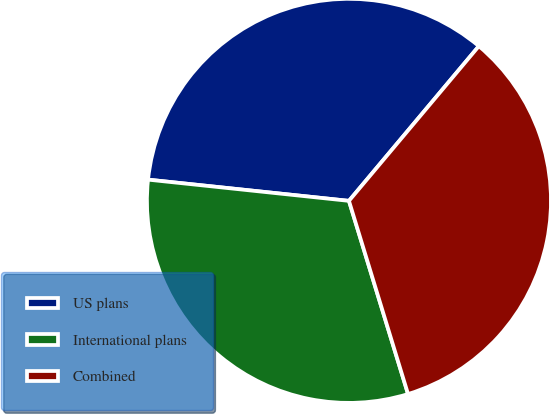Convert chart to OTSL. <chart><loc_0><loc_0><loc_500><loc_500><pie_chart><fcel>US plans<fcel>International plans<fcel>Combined<nl><fcel>34.44%<fcel>31.4%<fcel>34.16%<nl></chart> 